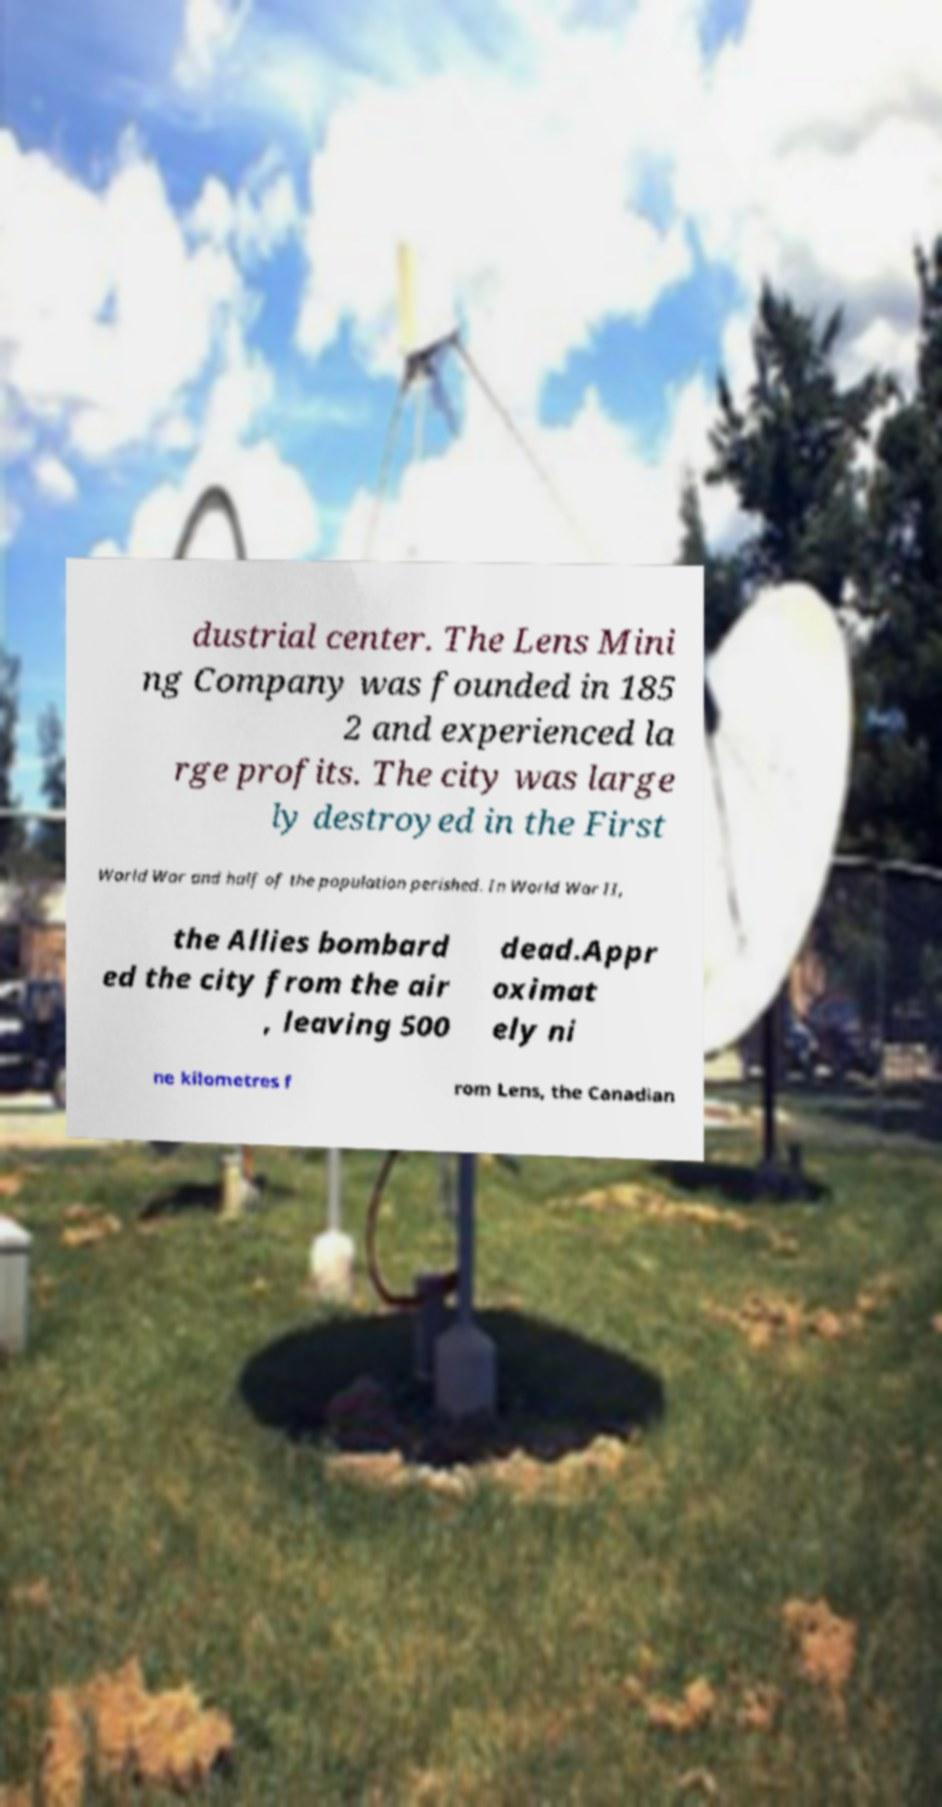There's text embedded in this image that I need extracted. Can you transcribe it verbatim? dustrial center. The Lens Mini ng Company was founded in 185 2 and experienced la rge profits. The city was large ly destroyed in the First World War and half of the population perished. In World War II, the Allies bombard ed the city from the air , leaving 500 dead.Appr oximat ely ni ne kilometres f rom Lens, the Canadian 